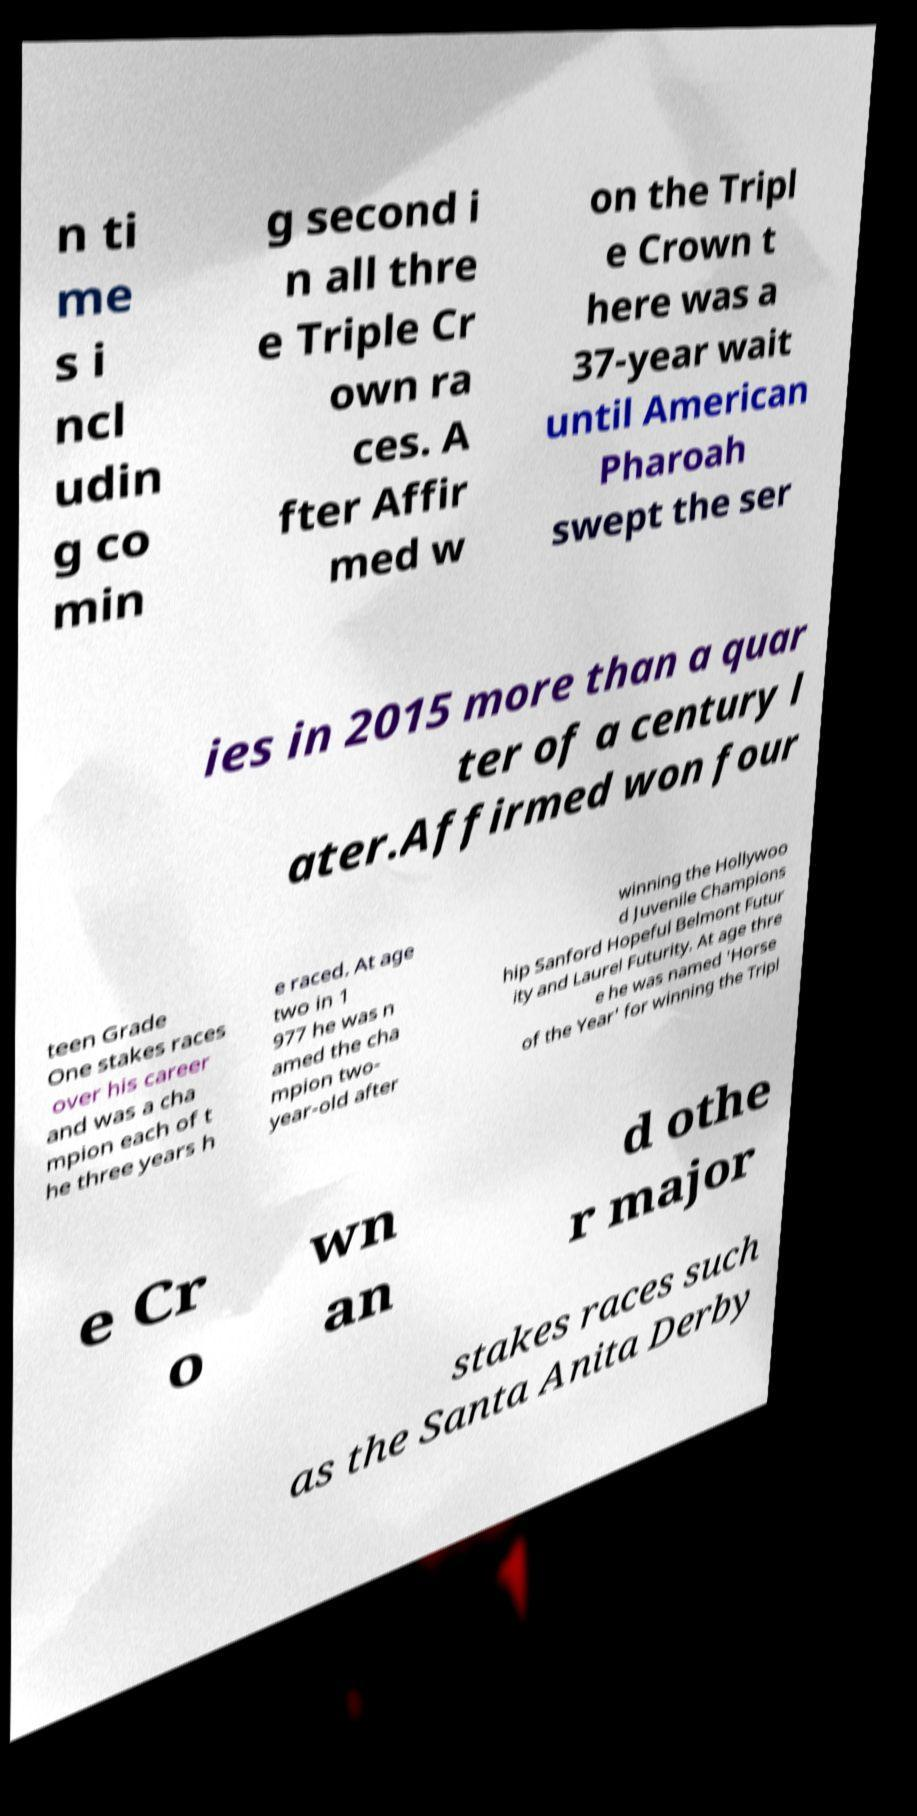Can you accurately transcribe the text from the provided image for me? n ti me s i ncl udin g co min g second i n all thre e Triple Cr own ra ces. A fter Affir med w on the Tripl e Crown t here was a 37-year wait until American Pharoah swept the ser ies in 2015 more than a quar ter of a century l ater.Affirmed won four teen Grade One stakes races over his career and was a cha mpion each of t he three years h e raced. At age two in 1 977 he was n amed the cha mpion two- year-old after winning the Hollywoo d Juvenile Champions hip Sanford Hopeful Belmont Futur ity and Laurel Futurity. At age thre e he was named 'Horse of the Year' for winning the Tripl e Cr o wn an d othe r major stakes races such as the Santa Anita Derby 